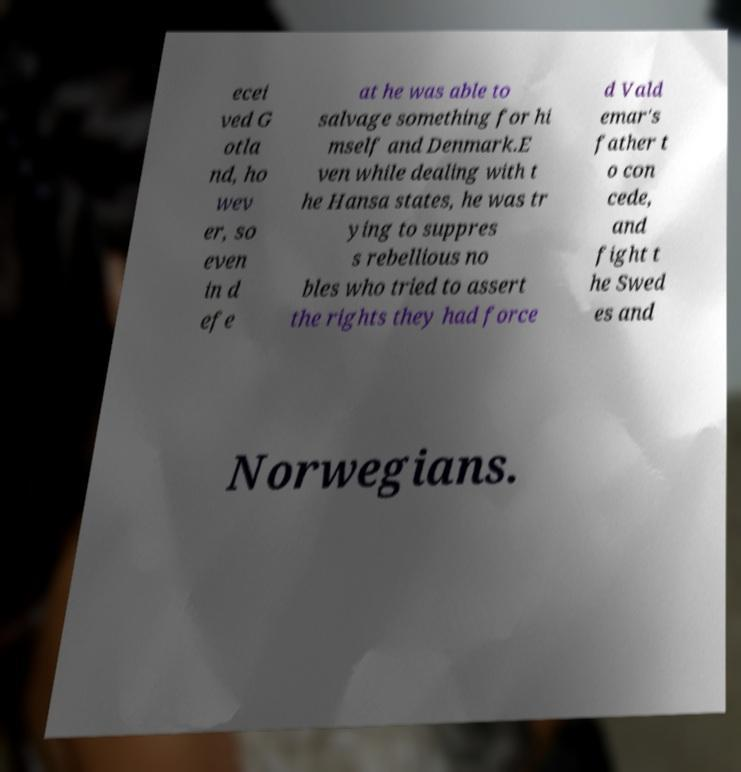For documentation purposes, I need the text within this image transcribed. Could you provide that? ecei ved G otla nd, ho wev er, so even in d efe at he was able to salvage something for hi mself and Denmark.E ven while dealing with t he Hansa states, he was tr ying to suppres s rebellious no bles who tried to assert the rights they had force d Vald emar's father t o con cede, and fight t he Swed es and Norwegians. 